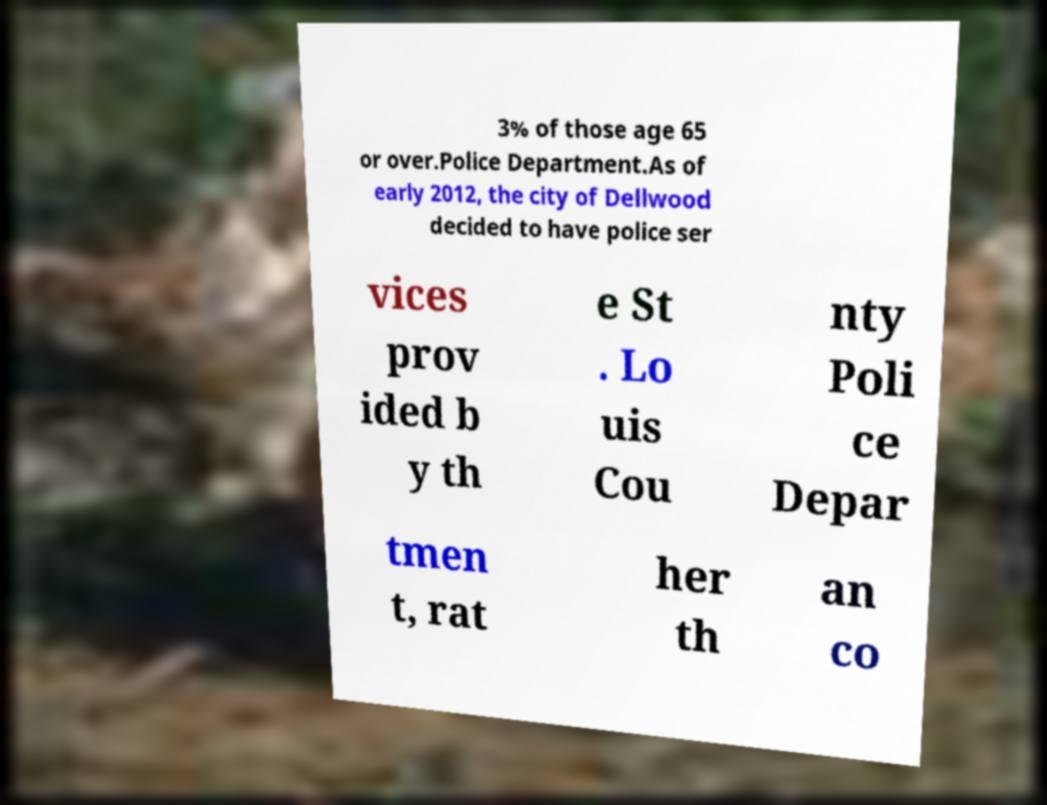What messages or text are displayed in this image? I need them in a readable, typed format. 3% of those age 65 or over.Police Department.As of early 2012, the city of Dellwood decided to have police ser vices prov ided b y th e St . Lo uis Cou nty Poli ce Depar tmen t, rat her th an co 